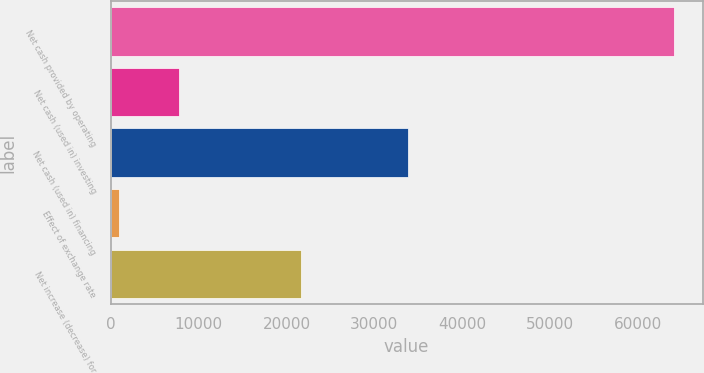<chart> <loc_0><loc_0><loc_500><loc_500><bar_chart><fcel>Net cash provided by operating<fcel>Net cash (used in) investing<fcel>Net cash (used in) financing<fcel>Effect of exchange rate<fcel>Net increase (decrease) for<nl><fcel>64146<fcel>7720<fcel>33849<fcel>924<fcel>21653<nl></chart> 